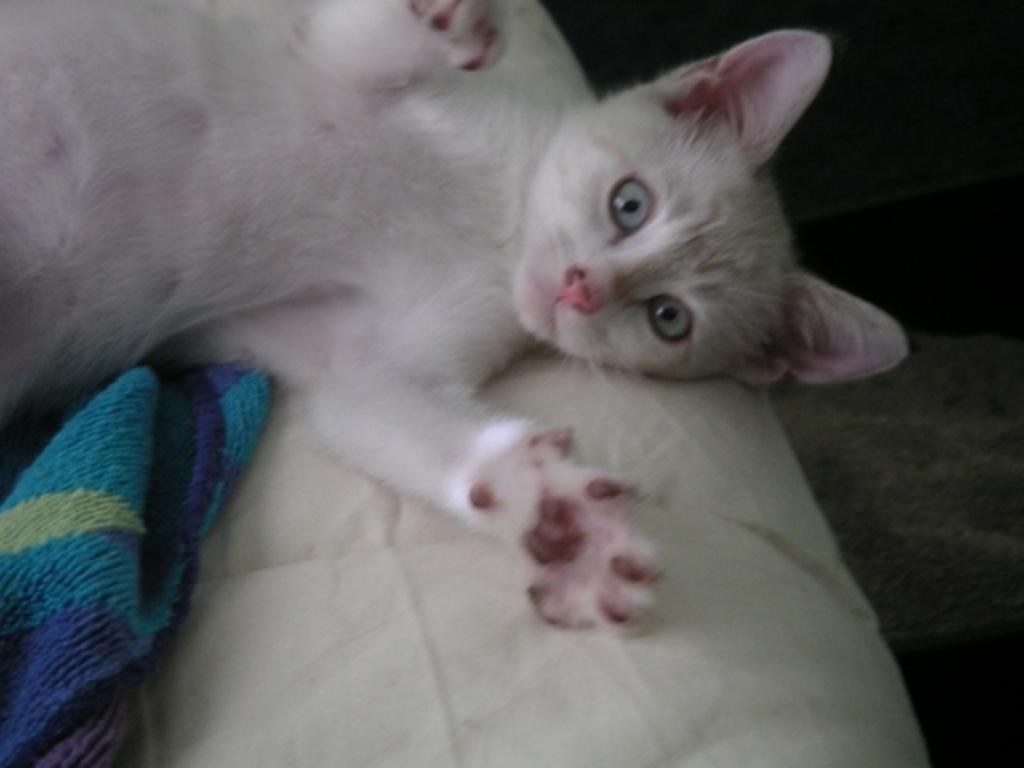What type of animal can be seen in the image? There is a cat in the image. What material is present in the image? There is cloth in the image. What color is the white object in the image? The white object in the image is white. What type of bone can be seen in the image? There is no bone present in the image. What type of wine is being served in the image? There is no wine present in the image. 